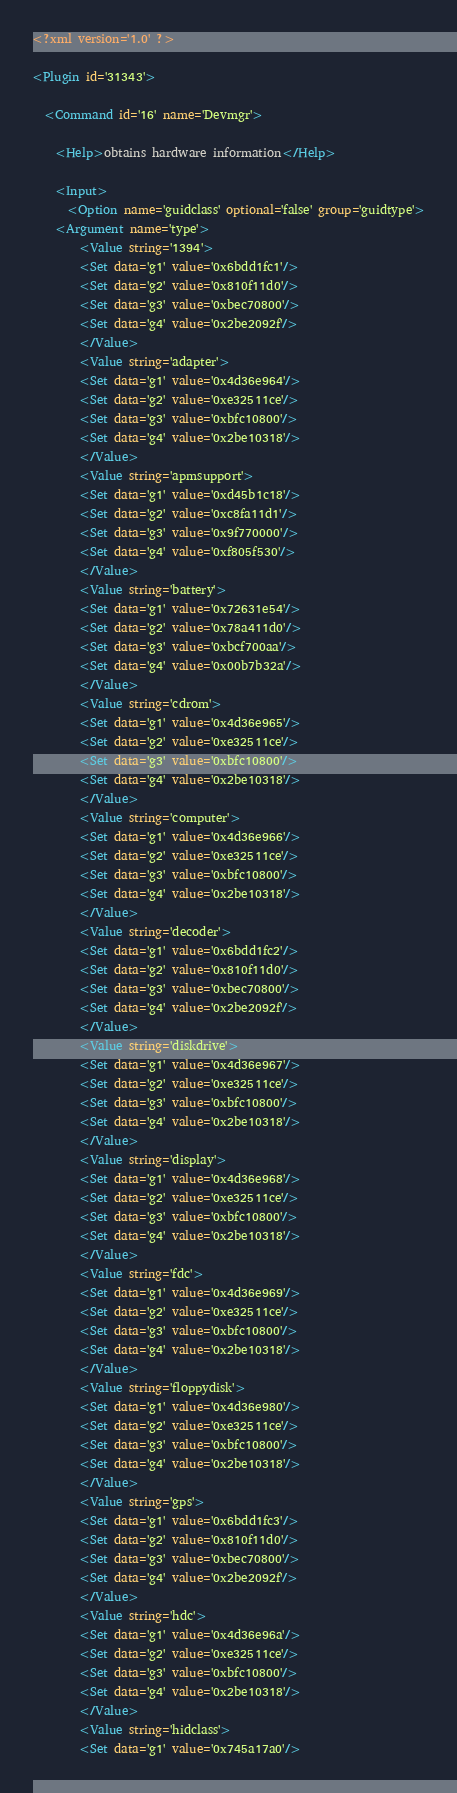<code> <loc_0><loc_0><loc_500><loc_500><_XML_><?xml version='1.0' ?>

<Plugin id='31343'>

  <Command id='16' name='Devmgr'>

    <Help>obtains hardware information</Help>

    <Input>
      <Option name='guidclass' optional='false' group='guidtype'>
	<Argument name='type'>
	    <Value string='1394'>
		<Set data='g1' value='0x6bdd1fc1'/>
		<Set data='g2' value='0x810f11d0'/>
		<Set data='g3' value='0xbec70800'/>
		<Set data='g4' value='0x2be2092f'/>
	    </Value>
	    <Value string='adapter'>
		<Set data='g1' value='0x4d36e964'/>
		<Set data='g2' value='0xe32511ce'/>
		<Set data='g3' value='0xbfc10800'/>
		<Set data='g4' value='0x2be10318'/>
	    </Value>
	    <Value string='apmsupport'>
		<Set data='g1' value='0xd45b1c18'/>
		<Set data='g2' value='0xc8fa11d1'/>
		<Set data='g3' value='0x9f770000'/>
		<Set data='g4' value='0xf805f530'/>
	    </Value>
	    <Value string='battery'>
		<Set data='g1' value='0x72631e54'/>
		<Set data='g2' value='0x78a411d0'/>
		<Set data='g3' value='0xbcf700aa'/>
		<Set data='g4' value='0x00b7b32a'/>
	    </Value>
	    <Value string='cdrom'>
		<Set data='g1' value='0x4d36e965'/>
		<Set data='g2' value='0xe32511ce'/>
		<Set data='g3' value='0xbfc10800'/>
		<Set data='g4' value='0x2be10318'/>
	    </Value>
	    <Value string='computer'>
		<Set data='g1' value='0x4d36e966'/>
		<Set data='g2' value='0xe32511ce'/>
		<Set data='g3' value='0xbfc10800'/>
		<Set data='g4' value='0x2be10318'/>
	    </Value>
	    <Value string='decoder'>
		<Set data='g1' value='0x6bdd1fc2'/>
		<Set data='g2' value='0x810f11d0'/>
		<Set data='g3' value='0xbec70800'/>
		<Set data='g4' value='0x2be2092f'/>
	    </Value>
	    <Value string='diskdrive'>
		<Set data='g1' value='0x4d36e967'/>
		<Set data='g2' value='0xe32511ce'/>
		<Set data='g3' value='0xbfc10800'/>
		<Set data='g4' value='0x2be10318'/>
	    </Value>
	    <Value string='display'>
		<Set data='g1' value='0x4d36e968'/>
		<Set data='g2' value='0xe32511ce'/>
		<Set data='g3' value='0xbfc10800'/>
		<Set data='g4' value='0x2be10318'/>
	    </Value>
	    <Value string='fdc'>
		<Set data='g1' value='0x4d36e969'/>
		<Set data='g2' value='0xe32511ce'/>
		<Set data='g3' value='0xbfc10800'/>
		<Set data='g4' value='0x2be10318'/>
	    </Value>
	    <Value string='floppydisk'>
		<Set data='g1' value='0x4d36e980'/>
		<Set data='g2' value='0xe32511ce'/>
		<Set data='g3' value='0xbfc10800'/>
		<Set data='g4' value='0x2be10318'/>
	    </Value>
	    <Value string='gps'>
		<Set data='g1' value='0x6bdd1fc3'/>
		<Set data='g2' value='0x810f11d0'/>
		<Set data='g3' value='0xbec70800'/>
		<Set data='g4' value='0x2be2092f'/>
	    </Value>
	    <Value string='hdc'>
		<Set data='g1' value='0x4d36e96a'/>
		<Set data='g2' value='0xe32511ce'/>
		<Set data='g3' value='0xbfc10800'/>
		<Set data='g4' value='0x2be10318'/>
	    </Value>
	    <Value string='hidclass'>
		<Set data='g1' value='0x745a17a0'/></code> 